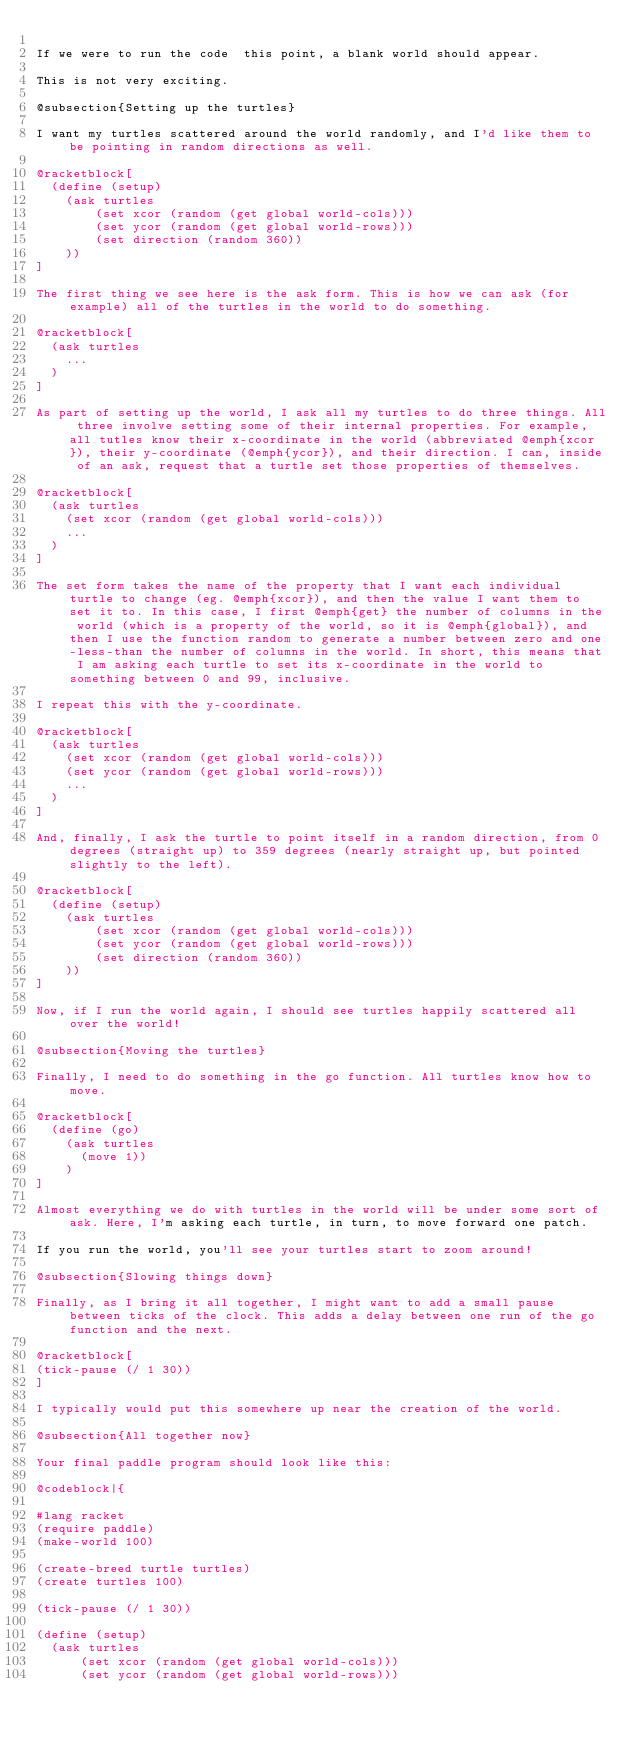<code> <loc_0><loc_0><loc_500><loc_500><_Racket_>
If we were to run the code  this point, a blank world should appear.

This is not very exciting.

@subsection{Setting up the turtles}

I want my turtles scattered around the world randomly, and I'd like them to be pointing in random directions as well.

@racketblock[
  (define (setup)
    (ask turtles
        (set xcor (random (get global world-cols)))
        (set ycor (random (get global world-rows)))
        (set direction (random 360))
    ))
]

The first thing we see here is the ask form. This is how we can ask (for example) all of the turtles in the world to do something.

@racketblock[
  (ask turtles
    ...
  )
]

As part of setting up the world, I ask all my turtles to do three things. All three involve setting some of their internal properties. For example, all tutles know their x-coordinate in the world (abbreviated @emph{xcor}), their y-coordinate (@emph{ycor}), and their direction. I can, inside of an ask, request that a turtle set those properties of themselves.

@racketblock[
  (ask turtles
    (set xcor (random (get global world-cols)))
    ...
  )
]

The set form takes the name of the property that I want each individual turtle to change (eg. @emph{xcor}), and then the value I want them to set it to. In this case, I first @emph{get} the number of columns in the world (which is a property of the world, so it is @emph{global}), and then I use the function random to generate a number between zero and one-less-than the number of columns in the world. In short, this means that I am asking each turtle to set its x-coordinate in the world to something between 0 and 99, inclusive.

I repeat this with the y-coordinate. 

@racketblock[
  (ask turtles
    (set xcor (random (get global world-cols)))
    (set ycor (random (get global world-rows)))
    ...
  )
]

And, finally, I ask the turtle to point itself in a random direction, from 0 degrees (straight up) to 359 degrees (nearly straight up, but pointed slightly to the left). 

@racketblock[
  (define (setup)
    (ask turtles
        (set xcor (random (get global world-cols)))
        (set ycor (random (get global world-rows)))
        (set direction (random 360))
    ))
]

Now, if I run the world again, I should see turtles happily scattered all over the world!

@subsection{Moving the turtles}

Finally, I need to do something in the go function. All turtles know how to move.

@racketblock[
  (define (go)
    (ask turtles
      (move 1))
    )
]

Almost everything we do with turtles in the world will be under some sort of ask. Here, I'm asking each turtle, in turn, to move forward one patch. 

If you run the world, you'll see your turtles start to zoom around!

@subsection{Slowing things down}

Finally, as I bring it all together, I might want to add a small pause between ticks of the clock. This adds a delay between one run of the go function and the next.

@racketblock[
(tick-pause (/ 1 30))
]

I typically would put this somewhere up near the creation of the world.

@subsection{All together now}

Your final paddle program should look like this:

@codeblock|{

#lang racket
(require paddle)
(make-world 100)

(create-breed turtle turtles)
(create turtles 100)

(tick-pause (/ 1 30))

(define (setup)
  (ask turtles
      (set xcor (random (get global world-cols)))
      (set ycor (random (get global world-rows)))</code> 